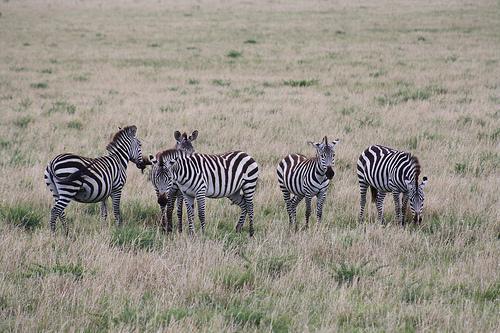How many zebras are there?
Give a very brief answer. 5. 